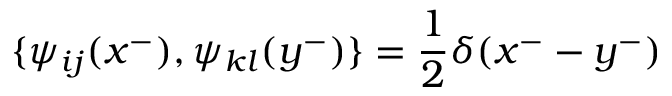<formula> <loc_0><loc_0><loc_500><loc_500>\{ \psi _ { i j } ( x ^ { - } ) , \psi _ { k l } ( y ^ { - } ) \} = \frac { 1 } { 2 } \delta ( x ^ { - } - y ^ { - } )</formula> 